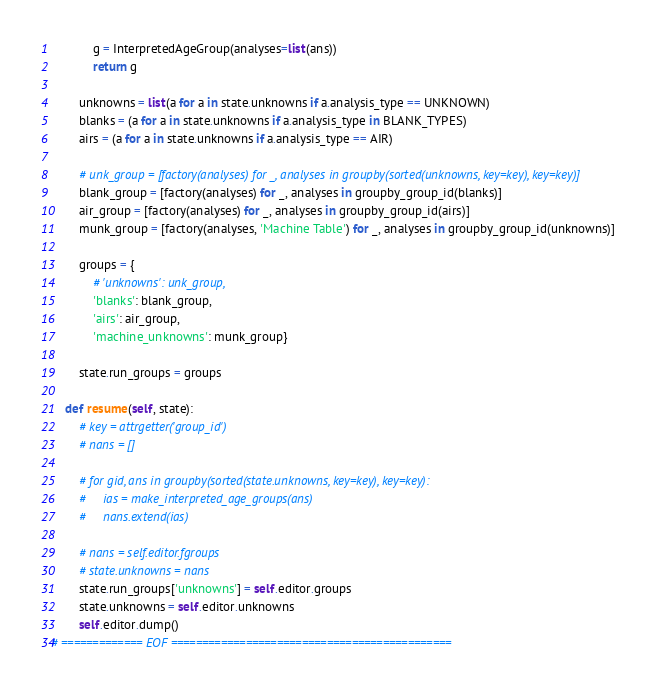<code> <loc_0><loc_0><loc_500><loc_500><_Python_>
            g = InterpretedAgeGroup(analyses=list(ans))
            return g

        unknowns = list(a for a in state.unknowns if a.analysis_type == UNKNOWN)
        blanks = (a for a in state.unknowns if a.analysis_type in BLANK_TYPES)
        airs = (a for a in state.unknowns if a.analysis_type == AIR)

        # unk_group = [factory(analyses) for _, analyses in groupby(sorted(unknowns, key=key), key=key)]
        blank_group = [factory(analyses) for _, analyses in groupby_group_id(blanks)]
        air_group = [factory(analyses) for _, analyses in groupby_group_id(airs)]
        munk_group = [factory(analyses, 'Machine Table') for _, analyses in groupby_group_id(unknowns)]

        groups = {
            # 'unknowns': unk_group,
            'blanks': blank_group,
            'airs': air_group,
            'machine_unknowns': munk_group}

        state.run_groups = groups

    def resume(self, state):
        # key = attrgetter('group_id')
        # nans = []

        # for gid, ans in groupby(sorted(state.unknowns, key=key), key=key):
        #     ias = make_interpreted_age_groups(ans)
        #     nans.extend(ias)

        # nans = self.editor.fgroups
        # state.unknowns = nans
        state.run_groups['unknowns'] = self.editor.groups
        state.unknowns = self.editor.unknowns
        self.editor.dump()
# ============= EOF =============================================
</code> 